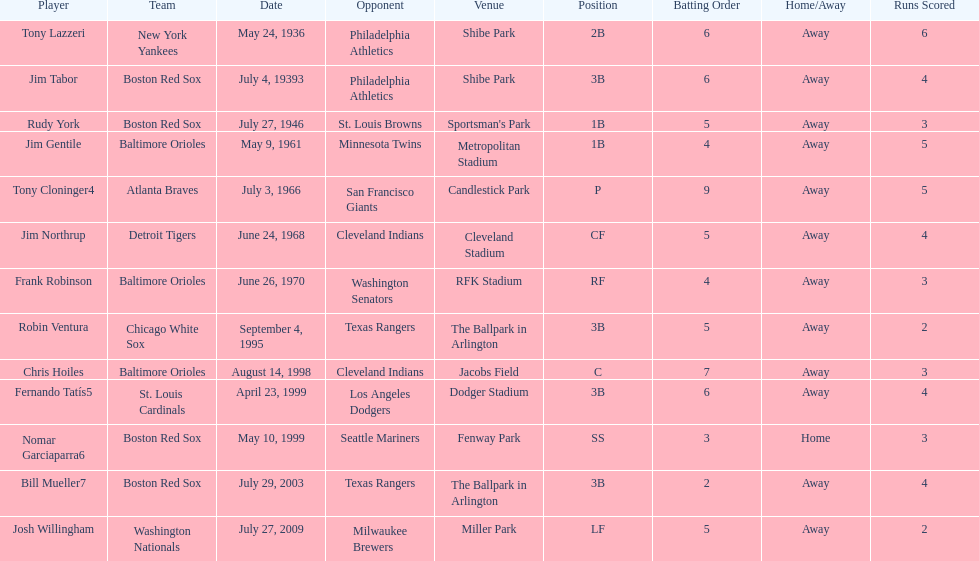Which teams faced off at miller park? Washington Nationals, Milwaukee Brewers. 